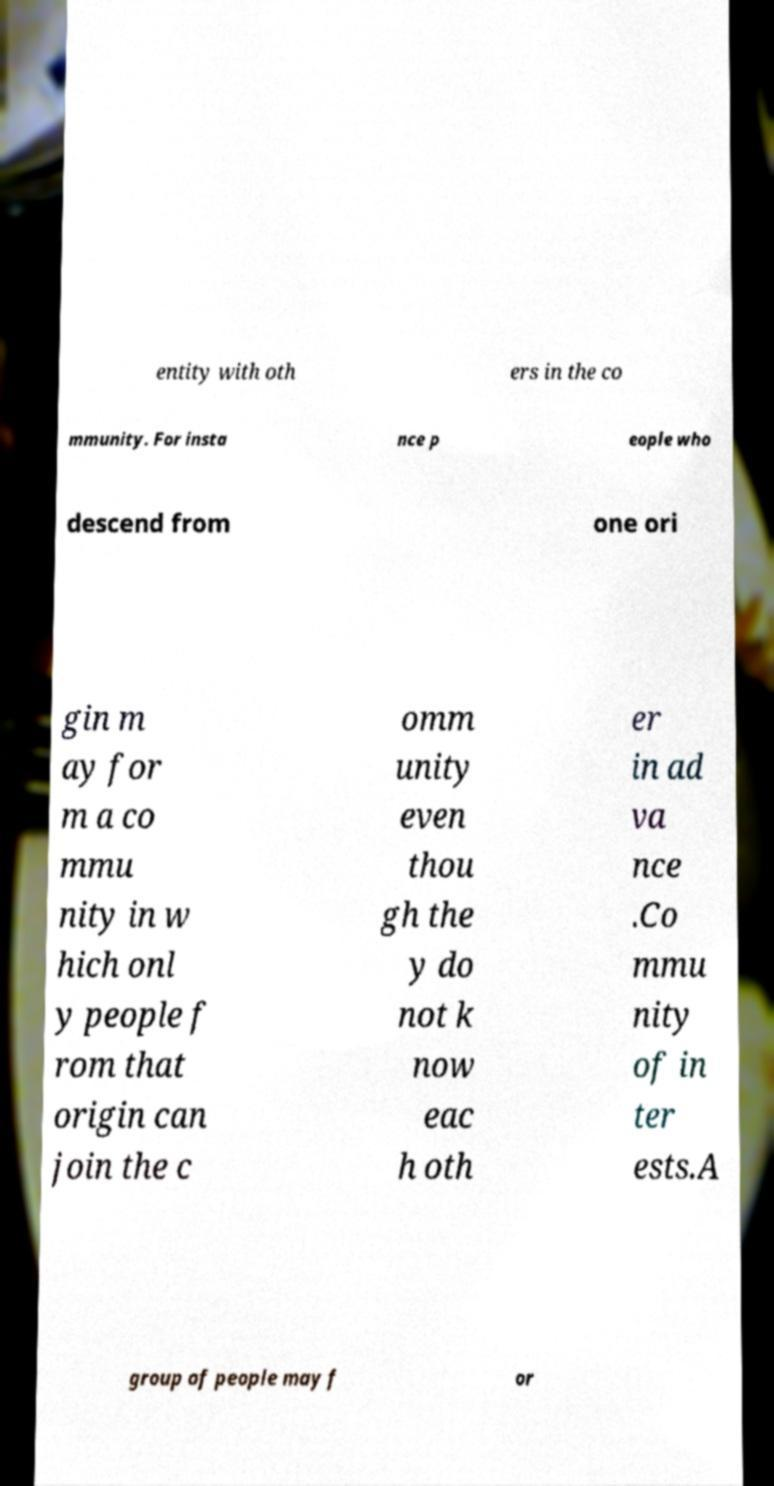I need the written content from this picture converted into text. Can you do that? entity with oth ers in the co mmunity. For insta nce p eople who descend from one ori gin m ay for m a co mmu nity in w hich onl y people f rom that origin can join the c omm unity even thou gh the y do not k now eac h oth er in ad va nce .Co mmu nity of in ter ests.A group of people may f or 